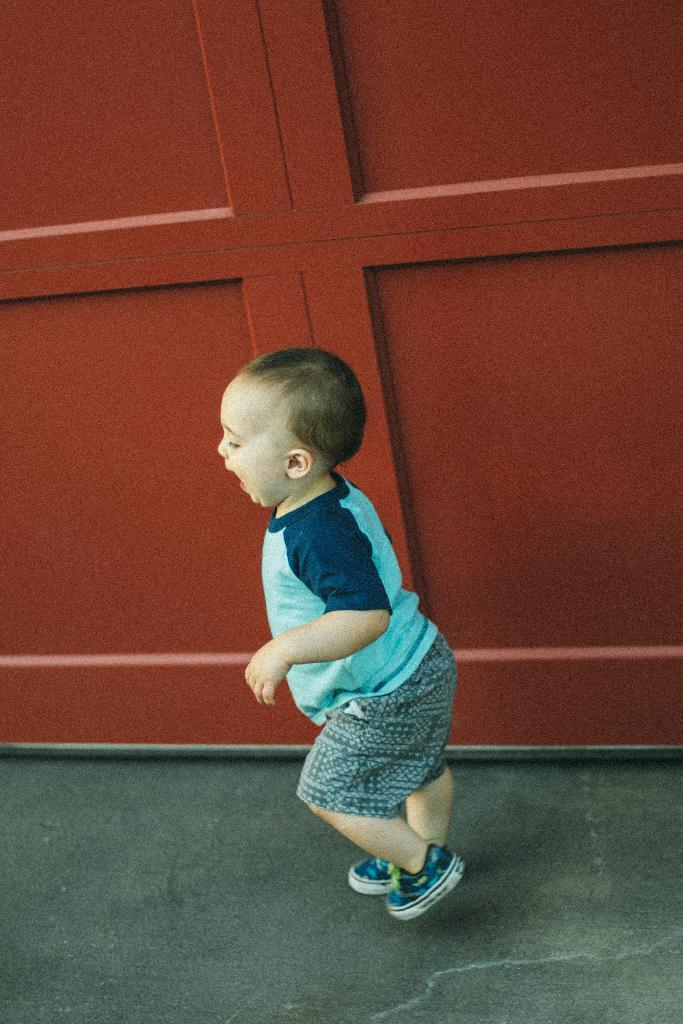What is the main subject of the image? The main subject of the image is a kid. Where is the kid located in the image? The kid is on the floor. What can be seen in the background of the image? There is a wooden wall in the background of the image. How many pets are visible in the image? There are no pets visible in the image. Did the wooden wall collapse during an earthquake in the image? There is no indication of an earthquake or a collapsed wall in the image. 